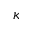<formula> <loc_0><loc_0><loc_500><loc_500>\kappa</formula> 